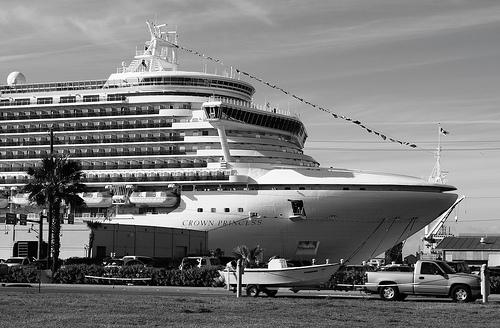Question: what time is it?
Choices:
A. Daytime.
B. Night time.
C. Evening.
D. Morning.
Answer with the letter. Answer: A Question: why is there a boat?
Choices:
A. To go fishing.
B. To transport people.
C. To jet ski behind.
D. To go to the beach.
Answer with the letter. Answer: B Question: when was the photo taken?
Choices:
A. Morning.
B. Evening.
C. Afternoon.
D. After Dinner.
Answer with the letter. Answer: C Question: what is in the background?
Choices:
A. The sky.
B. Mountains.
C. City skyline.
D. Grass field.
Answer with the letter. Answer: A 